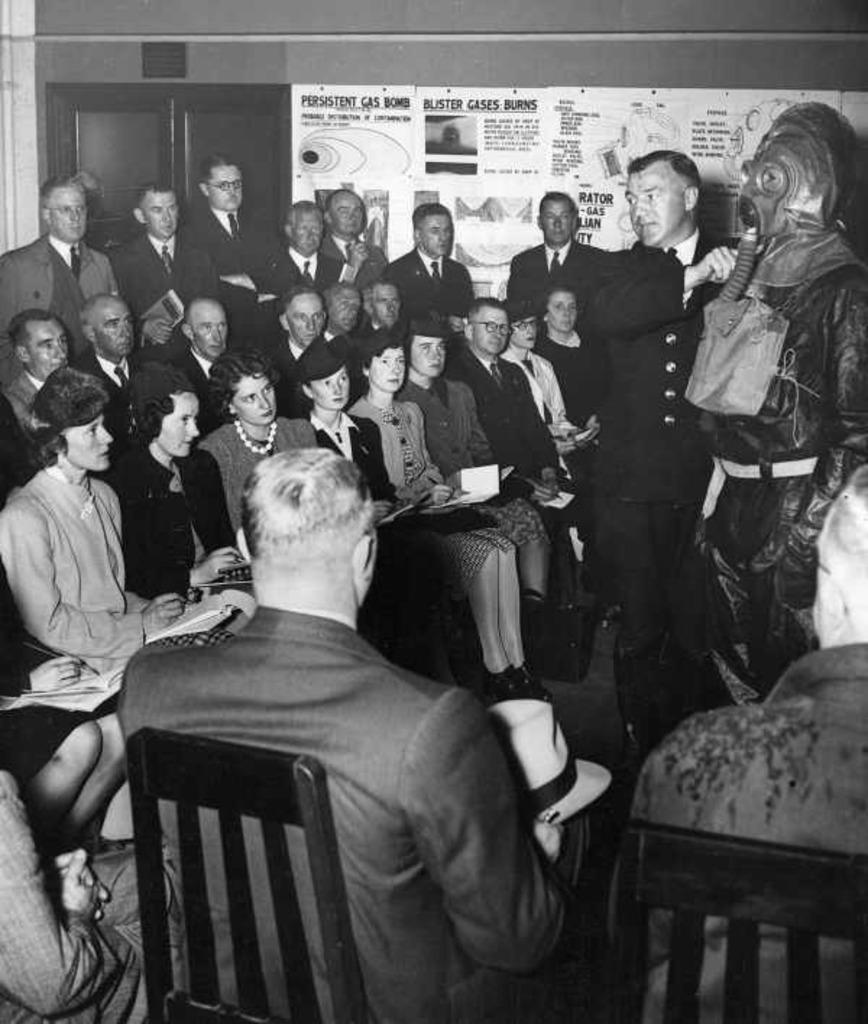In one or two sentences, can you explain what this image depicts? As we can see in the image, there are a group of people sitting and standing and there is a brown color wall, A banner is attached to the wall. 